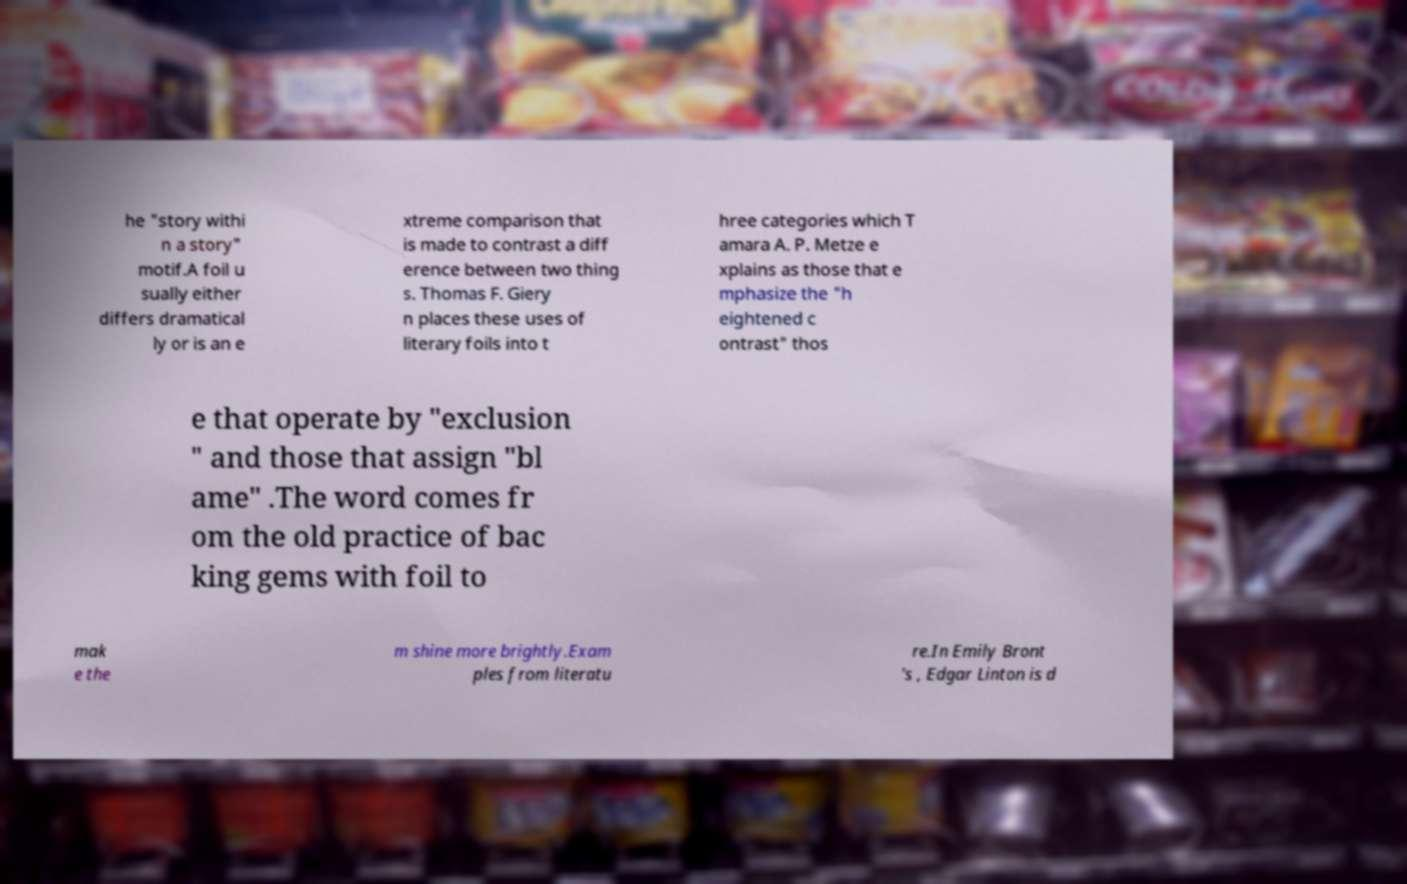I need the written content from this picture converted into text. Can you do that? he "story withi n a story" motif.A foil u sually either differs dramatical ly or is an e xtreme comparison that is made to contrast a diff erence between two thing s. Thomas F. Giery n places these uses of literary foils into t hree categories which T amara A. P. Metze e xplains as those that e mphasize the "h eightened c ontrast" thos e that operate by "exclusion " and those that assign "bl ame" .The word comes fr om the old practice of bac king gems with foil to mak e the m shine more brightly.Exam ples from literatu re.In Emily Bront 's , Edgar Linton is d 